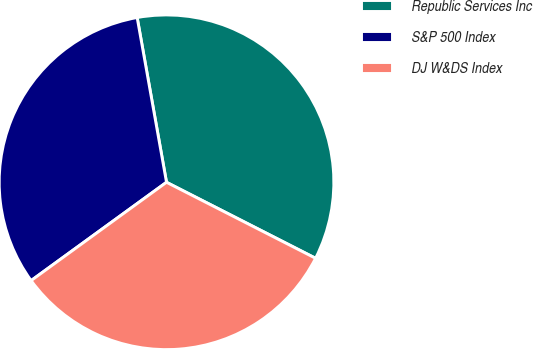Convert chart. <chart><loc_0><loc_0><loc_500><loc_500><pie_chart><fcel>Republic Services Inc<fcel>S&P 500 Index<fcel>DJ W&DS Index<nl><fcel>35.31%<fcel>32.19%<fcel>32.5%<nl></chart> 